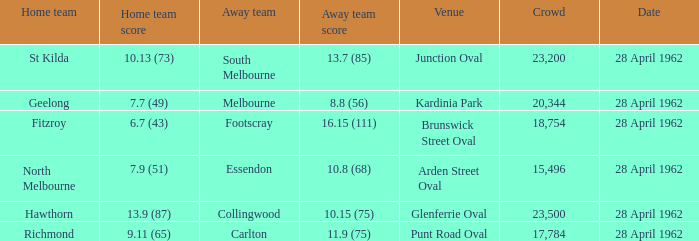Which visiting team competed at brunswick street oval? Footscray. 